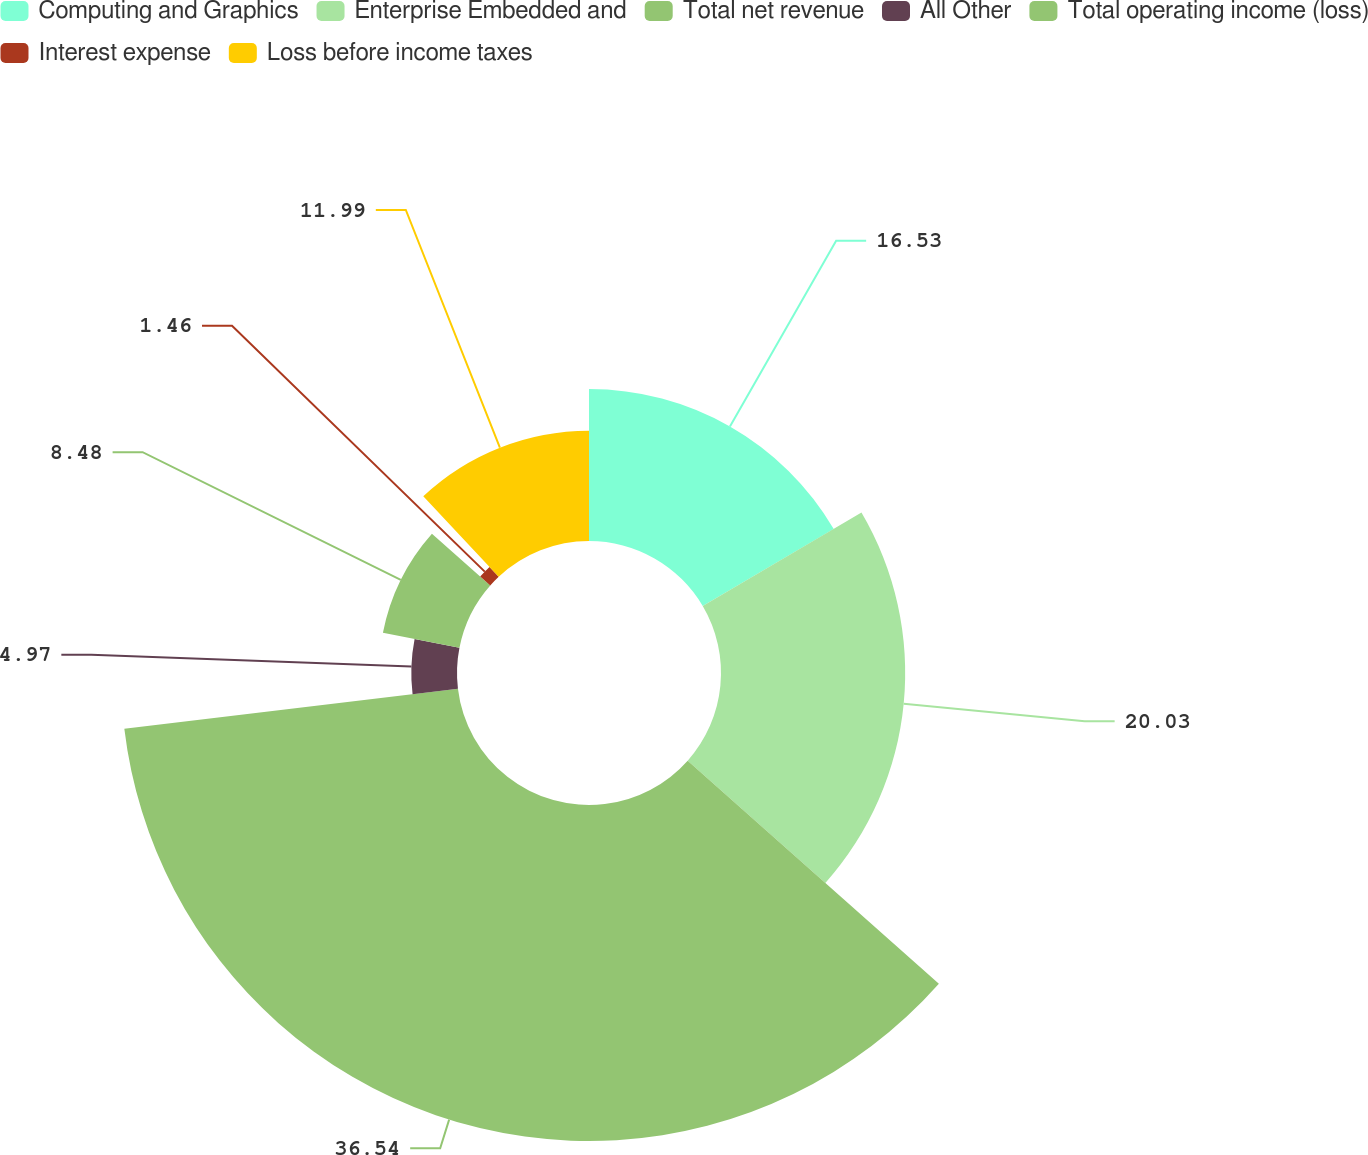Convert chart to OTSL. <chart><loc_0><loc_0><loc_500><loc_500><pie_chart><fcel>Computing and Graphics<fcel>Enterprise Embedded and<fcel>Total net revenue<fcel>All Other<fcel>Total operating income (loss)<fcel>Interest expense<fcel>Loss before income taxes<nl><fcel>16.53%<fcel>20.03%<fcel>36.54%<fcel>4.97%<fcel>8.48%<fcel>1.46%<fcel>11.99%<nl></chart> 